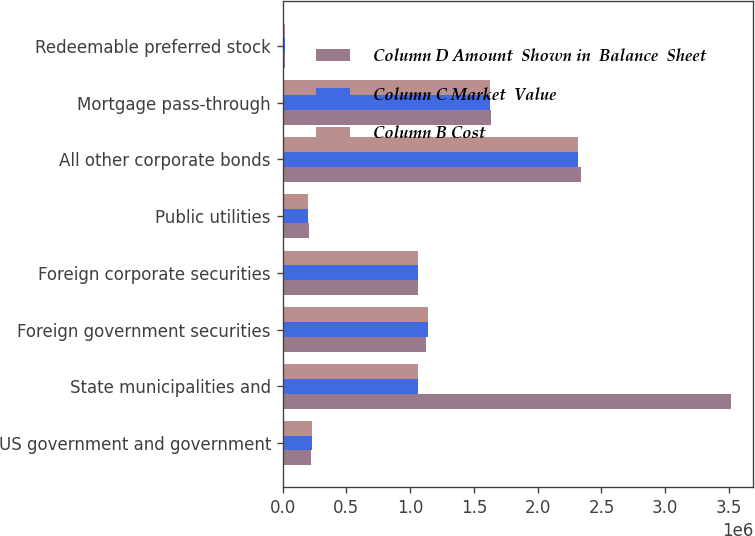<chart> <loc_0><loc_0><loc_500><loc_500><stacked_bar_chart><ecel><fcel>US government and government<fcel>State municipalities and<fcel>Foreign government securities<fcel>Foreign corporate securities<fcel>Public utilities<fcel>All other corporate bonds<fcel>Mortgage pass-through<fcel>Redeemable preferred stock<nl><fcel>Column D Amount  Shown in  Balance  Sheet<fcel>224563<fcel>3.51269e+06<fcel>1.12299e+06<fcel>1.06176e+06<fcel>205186<fcel>2.33596e+06<fcel>1.63654e+06<fcel>16654<nl><fcel>Column C Market  Value<fcel>231621<fcel>1.06137e+06<fcel>1.14162e+06<fcel>1.06097e+06<fcel>203095<fcel>2.31594e+06<fcel>1.62724e+06<fcel>16573<nl><fcel>Column B Cost<fcel>231621<fcel>1.06137e+06<fcel>1.14162e+06<fcel>1.06097e+06<fcel>203095<fcel>2.31594e+06<fcel>1.62724e+06<fcel>16573<nl></chart> 